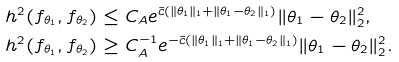Convert formula to latex. <formula><loc_0><loc_0><loc_500><loc_500>h ^ { 2 } ( f _ { \theta _ { 1 } } , f _ { \theta _ { 2 } } ) & \leq C _ { A } e ^ { \tilde { c } ( \| \theta _ { 1 } \| _ { 1 } + \| \theta _ { 1 } - \theta _ { 2 } \| _ { 1 } ) } \| \theta _ { 1 } - \theta _ { 2 } \| _ { 2 } ^ { 2 } , \\ h ^ { 2 } ( f _ { \theta _ { 1 } } , f _ { \theta _ { 2 } } ) & \geq C _ { A } ^ { - 1 } e ^ { - \tilde { c } ( \| \theta _ { 1 } \| _ { 1 } + \| \theta _ { 1 } - \theta _ { 2 } \| _ { 1 } ) } \| \theta _ { 1 } - \theta _ { 2 } \| _ { 2 } ^ { 2 } .</formula> 